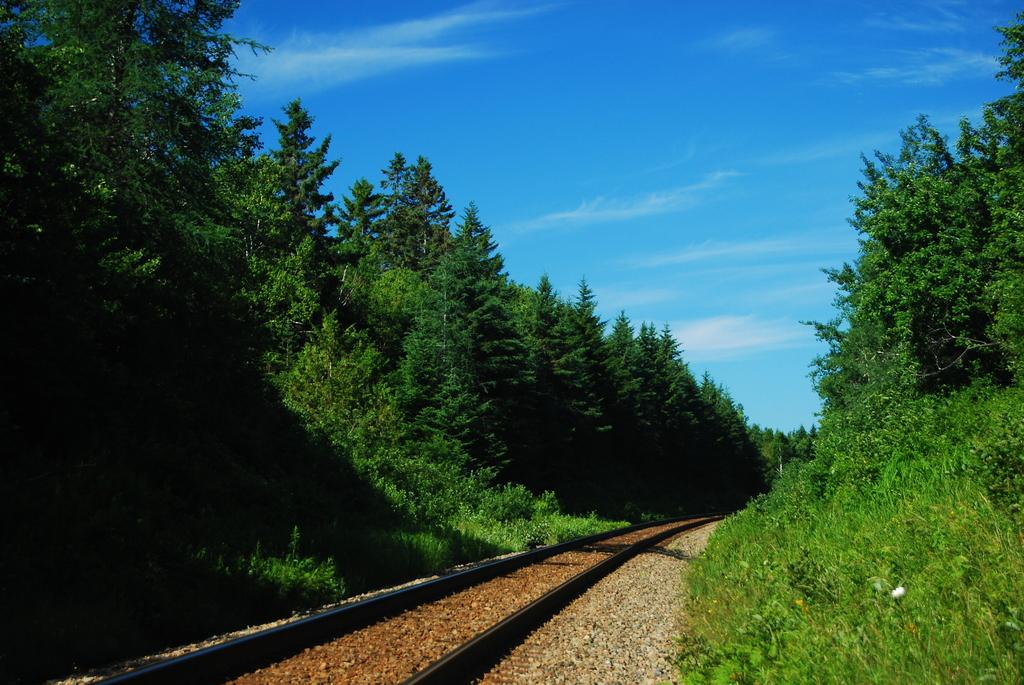What type of transportation infrastructure is shown in the image? There is a railway track in the image. What type of vegetation is present in the image? Grass, plants, and trees are visible in the image. What can be seen in the background of the image? The sky is visible in the background of the image. What type of stew is being prepared on the railway track in the image? There is no stew or cooking activity present in the image; it only features a railway track and natural elements. 